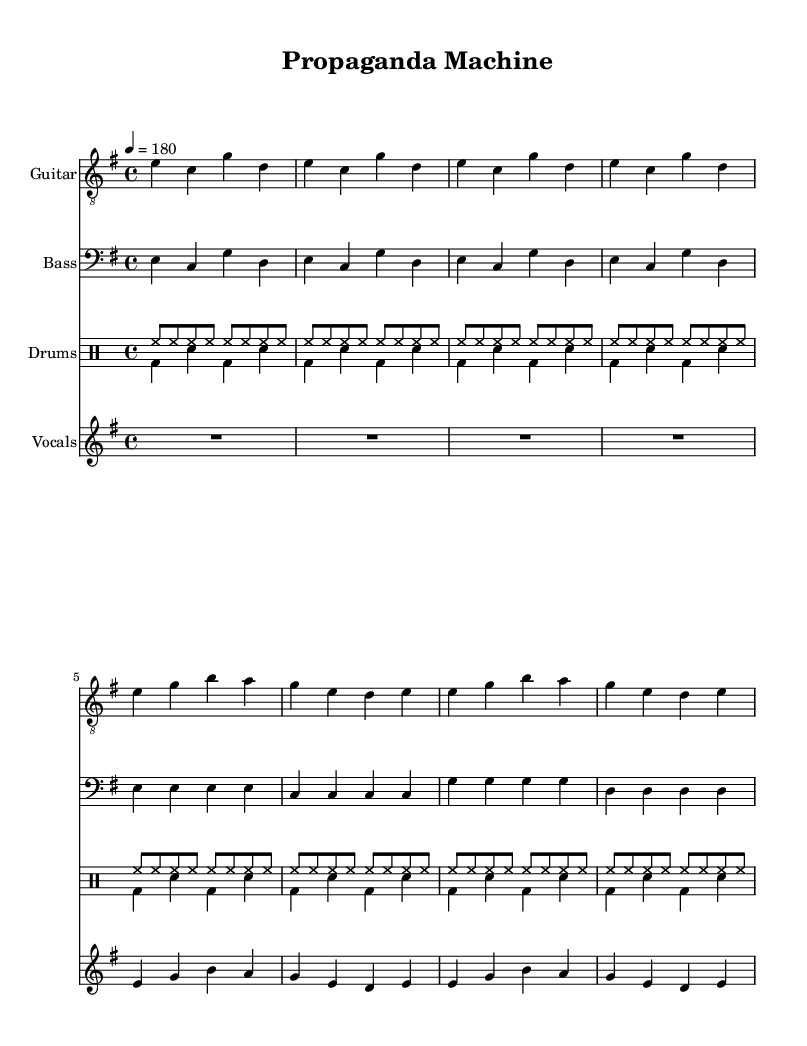What is the key signature of this music? The key signature is indicated at the beginning of the piece and shows one sharp, suggesting it is in E minor with no additional sharps or flats.
Answer: E minor What is the time signature used in the score? The time signature is located just after the key signature and indicates four beats in each measure, which is written as 4/4.
Answer: 4/4 What is the tempo marking for the piece? The tempo marking is shown at the beginning of the score, stating "4 = 180," which means there should be 180 beats per minute.
Answer: 180 What instruments are included in the score? The instruments are listed at the beginning of their respective staves, showing Guitar, Bass, Drums, and Vocals.
Answer: Guitar, Bass, Drums, Vocals How many measures are in the intro section of the music? The intro consists of four identical measures as shown by the notation repeating the same rhythmic pattern throughout.
Answer: 4 Analyze the vocal lyrics' theme based on the title "Propaganda Machine." What kind of content does it imply? The title suggests that the lyrics deal with the ideas of deception and control, which relate to the role of military propaganda in influencing public opinion. The lyrics hint at scrutiny of how information is manipulated to serve particular agendas.
Answer: Deception and control In what style does the piece exhibit characteristics typical of Anarcho-punk? Anarcho-punk often critiques government and military institutions, which could be reflected in the aggressive tempo, straightforward rhythmic patterns, and critical lyrics focused on propaganda, as represented in the content of the song.
Answer: Critical of government and military institutions 